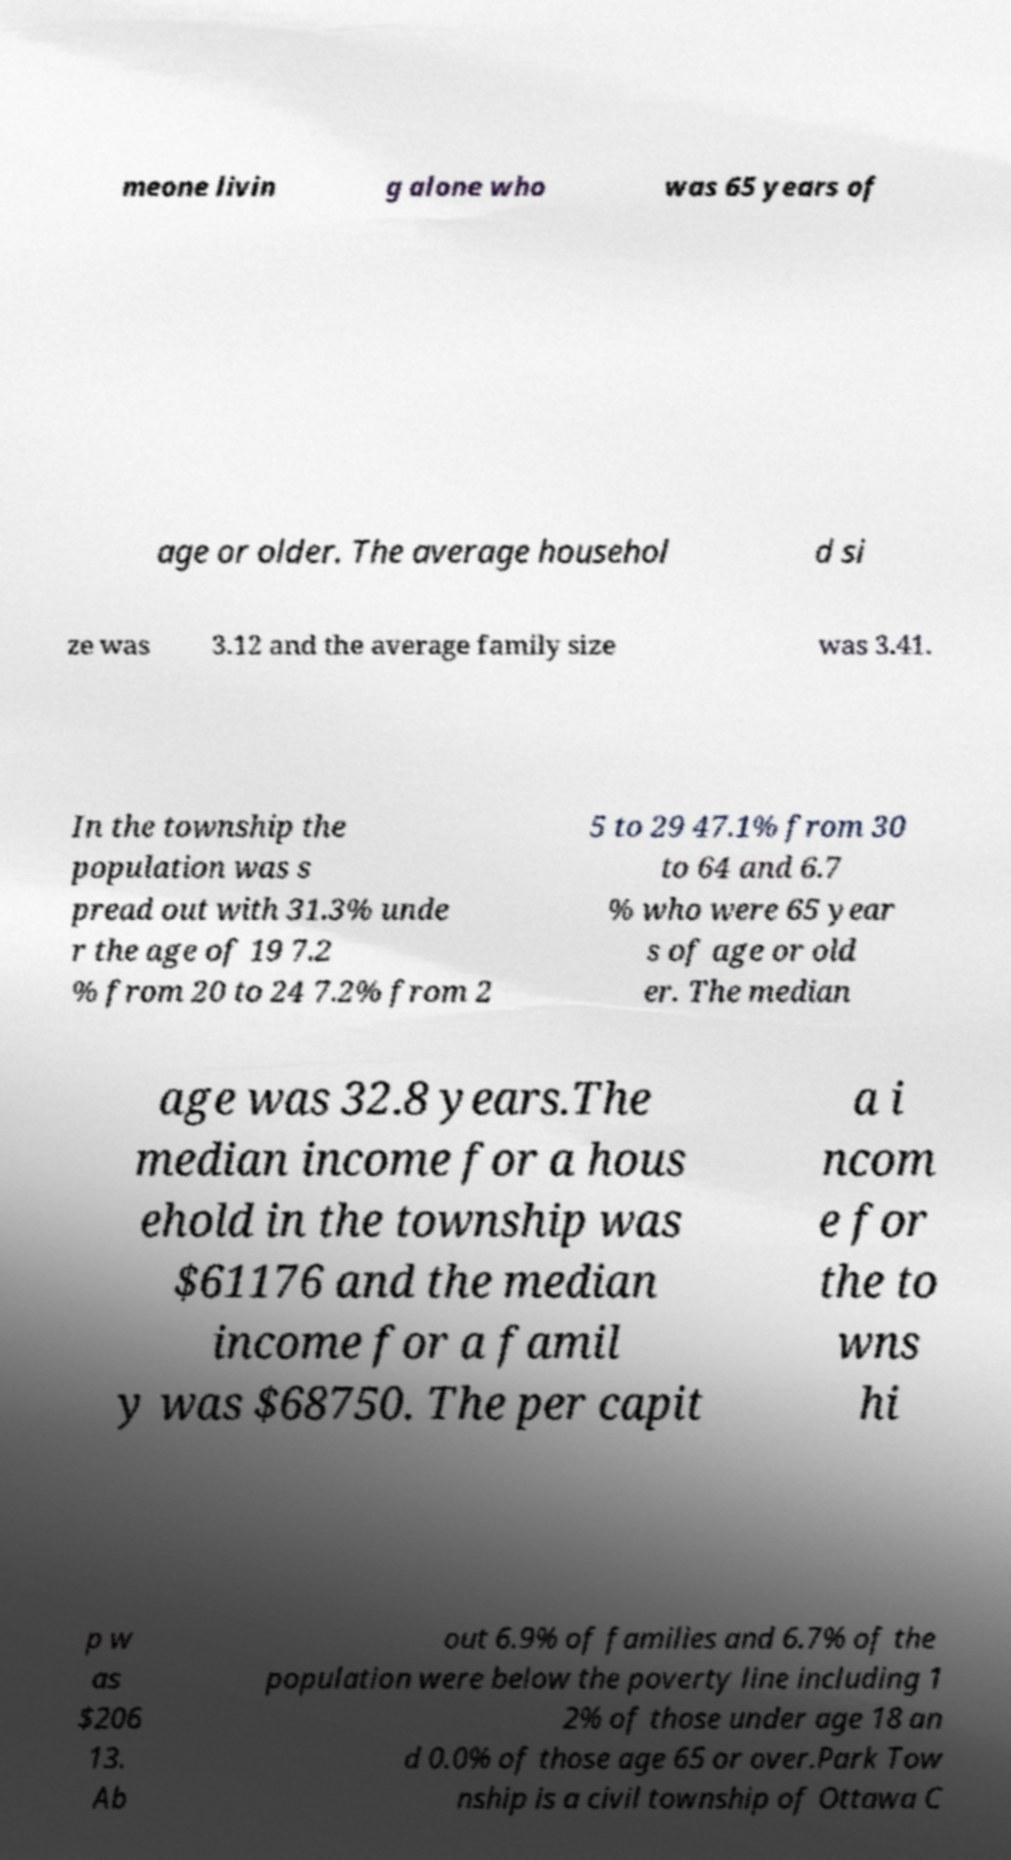There's text embedded in this image that I need extracted. Can you transcribe it verbatim? meone livin g alone who was 65 years of age or older. The average househol d si ze was 3.12 and the average family size was 3.41. In the township the population was s pread out with 31.3% unde r the age of 19 7.2 % from 20 to 24 7.2% from 2 5 to 29 47.1% from 30 to 64 and 6.7 % who were 65 year s of age or old er. The median age was 32.8 years.The median income for a hous ehold in the township was $61176 and the median income for a famil y was $68750. The per capit a i ncom e for the to wns hi p w as $206 13. Ab out 6.9% of families and 6.7% of the population were below the poverty line including 1 2% of those under age 18 an d 0.0% of those age 65 or over.Park Tow nship is a civil township of Ottawa C 